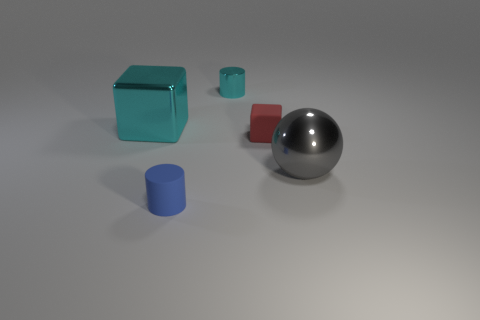Add 3 purple rubber balls. How many objects exist? 8 Subtract all cylinders. How many objects are left? 3 Subtract all big yellow rubber spheres. Subtract all large cyan metallic objects. How many objects are left? 4 Add 4 gray shiny objects. How many gray shiny objects are left? 5 Add 3 brown matte balls. How many brown matte balls exist? 3 Subtract 0 red cylinders. How many objects are left? 5 